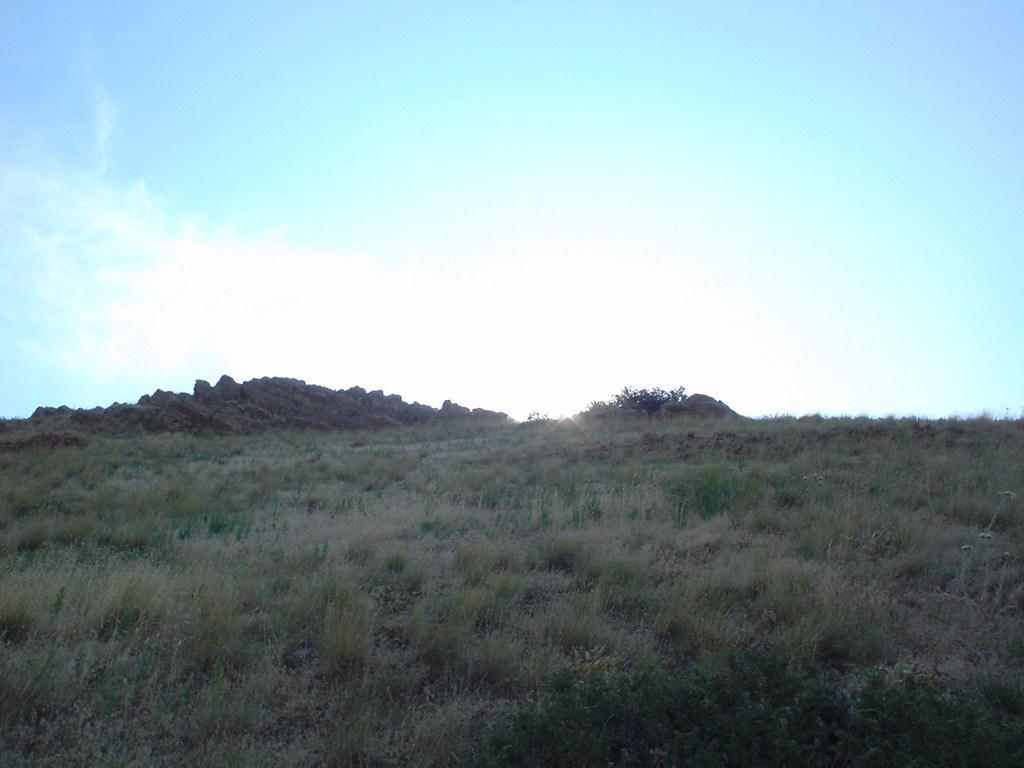Could you give a brief overview of what you see in this image? In this image there is a grassland and a hill, in the background there is the sky. 